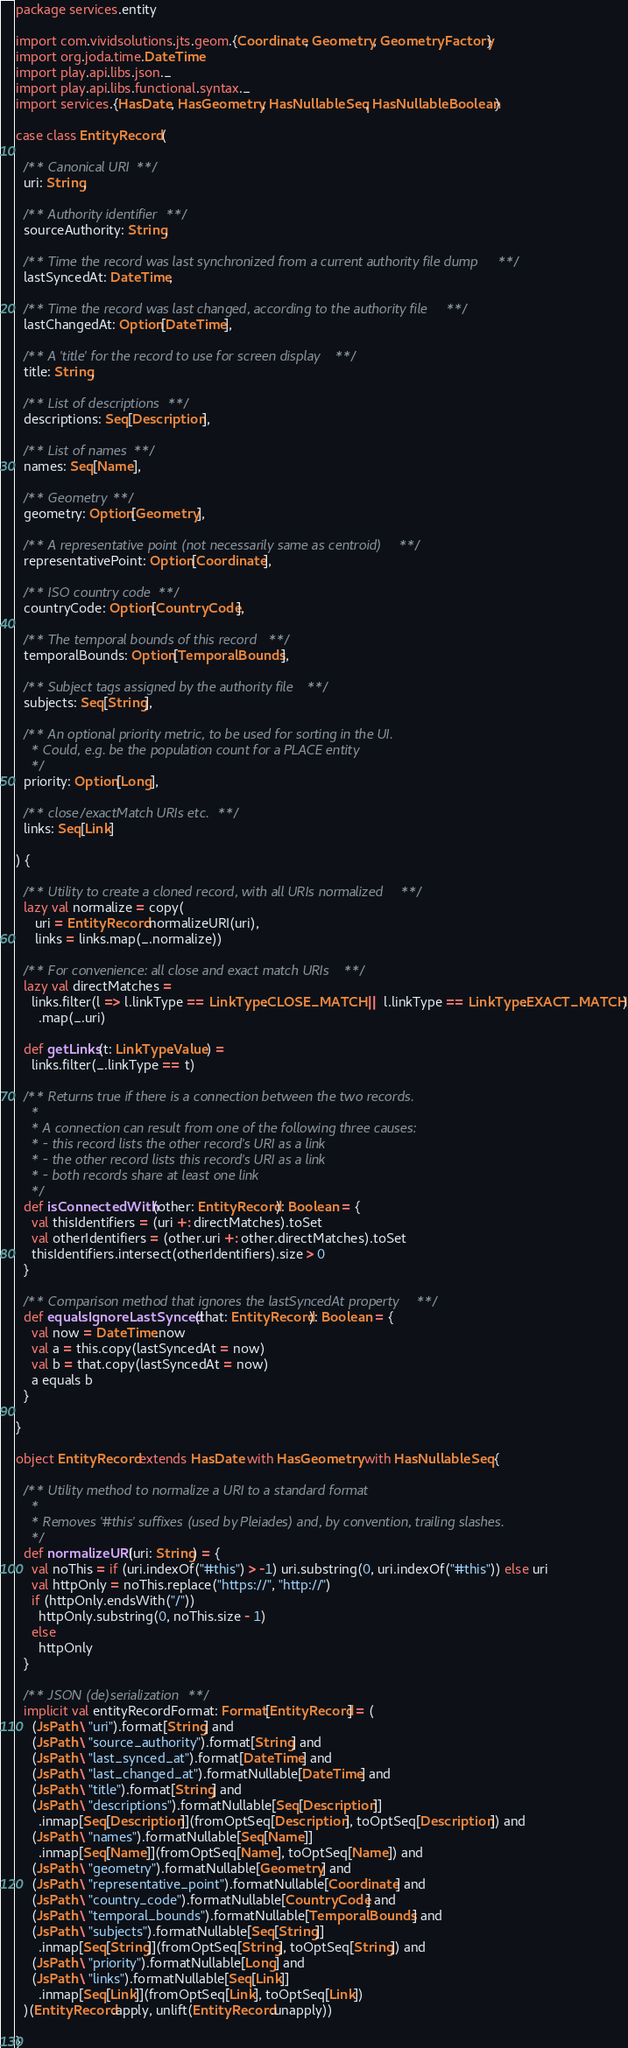Convert code to text. <code><loc_0><loc_0><loc_500><loc_500><_Scala_>package services.entity

import com.vividsolutions.jts.geom.{Coordinate, Geometry, GeometryFactory}
import org.joda.time.DateTime
import play.api.libs.json._
import play.api.libs.functional.syntax._
import services.{HasDate, HasGeometry, HasNullableSeq, HasNullableBoolean}

case class EntityRecord (

  /** Canonical URI **/
  uri: String,

  /** Authority identifier **/
  sourceAuthority: String,

  /** Time the record was last synchronized from a current authority file dump **/
  lastSyncedAt: DateTime,

  /** Time the record was last changed, according to the authority file **/
  lastChangedAt: Option[DateTime],

  /** A 'title' for the record to use for screen display **/
  title: String,

  /** List of descriptions **/
  descriptions: Seq[Description],

  /** List of names **/
  names: Seq[Name],

  /** Geometry **/
  geometry: Option[Geometry],

  /** A representative point (not necessarily same as centroid) **/
  representativePoint: Option[Coordinate],

  /** ISO country code **/
  countryCode: Option[CountryCode],

  /** The temporal bounds of this record **/
  temporalBounds: Option[TemporalBounds],

  /** Subject tags assigned by the authority file **/
  subjects: Seq[String],

  /** An optional priority metric, to be used for sorting in the UI.
    * Could, e.g. be the population count for a PLACE entity
    */
  priority: Option[Long],

  /** close/exactMatch URIs etc. **/
  links: Seq[Link]

) {

  /** Utility to create a cloned record, with all URIs normalized **/
  lazy val normalize = copy(
     uri = EntityRecord.normalizeURI(uri),
     links = links.map(_.normalize))
  
  /** For convenience: all close and exact match URIs **/
  lazy val directMatches =
    links.filter(l => l.linkType == LinkType.CLOSE_MATCH || l.linkType == LinkType.EXACT_MATCH)
      .map(_.uri)

  def getLinks(t: LinkType.Value) =
    links.filter(_.linkType == t)

  /** Returns true if there is a connection between the two records.
    *
    * A connection can result from one of the following three causes:
    * - this record lists the other record's URI as a link
    * - the other record lists this record's URI as a link
    * - both records share at least one link
    */
  def isConnectedWith(other: EntityRecord): Boolean = {
    val thisIdentifiers = (uri +: directMatches).toSet
    val otherIdentifiers = (other.uri +: other.directMatches).toSet
    thisIdentifiers.intersect(otherIdentifiers).size > 0
  }
  
  /** Comparison method that ignores the lastSyncedAt property **/
  def equalsIgnoreLastSynced(that: EntityRecord): Boolean = {
    val now = DateTime.now
    val a = this.copy(lastSyncedAt = now)
    val b = that.copy(lastSyncedAt = now)
    a equals b
  }
  
}

object EntityRecord extends HasDate with HasGeometry with HasNullableSeq {

  /** Utility method to normalize a URI to a standard format
    *
    * Removes '#this' suffixes (used by Pleiades) and, by convention, trailing slashes.
    */
  def normalizeURI(uri: String) = {
    val noThis = if (uri.indexOf("#this") > -1) uri.substring(0, uri.indexOf("#this")) else uri
    val httpOnly = noThis.replace("https://", "http://")
    if (httpOnly.endsWith("/"))
      httpOnly.substring(0, noThis.size - 1)
    else
      httpOnly
  }

  /** JSON (de)serialization **/
  implicit val entityRecordFormat: Format[EntityRecord] = (
    (JsPath \ "uri").format[String] and
    (JsPath \ "source_authority").format[String] and
    (JsPath \ "last_synced_at").format[DateTime] and
    (JsPath \ "last_changed_at").formatNullable[DateTime] and
    (JsPath \ "title").format[String] and
    (JsPath \ "descriptions").formatNullable[Seq[Description]]
      .inmap[Seq[Description]](fromOptSeq[Description], toOptSeq[Description]) and
    (JsPath \ "names").formatNullable[Seq[Name]]
      .inmap[Seq[Name]](fromOptSeq[Name], toOptSeq[Name]) and
    (JsPath \ "geometry").formatNullable[Geometry] and
    (JsPath \ "representative_point").formatNullable[Coordinate] and
    (JsPath \ "country_code").formatNullable[CountryCode] and
    (JsPath \ "temporal_bounds").formatNullable[TemporalBounds] and
    (JsPath \ "subjects").formatNullable[Seq[String]]
      .inmap[Seq[String]](fromOptSeq[String], toOptSeq[String]) and
    (JsPath \ "priority").formatNullable[Long] and
    (JsPath \ "links").formatNullable[Seq[Link]]
      .inmap[Seq[Link]](fromOptSeq[Link], toOptSeq[Link])
  )(EntityRecord.apply, unlift(EntityRecord.unapply))

}
</code> 